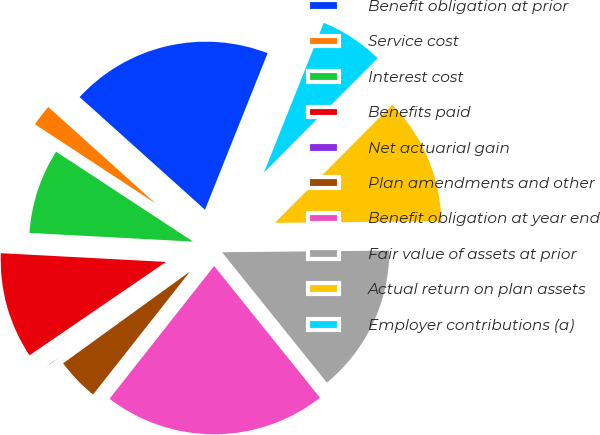<chart> <loc_0><loc_0><loc_500><loc_500><pie_chart><fcel>Benefit obligation at prior<fcel>Service cost<fcel>Interest cost<fcel>Benefits paid<fcel>Net actuarial gain<fcel>Plan amendments and other<fcel>Benefit obligation at year end<fcel>Fair value of assets at prior<fcel>Actual return on plan assets<fcel>Employer contributions (a)<nl><fcel>19.4%<fcel>2.41%<fcel>8.4%<fcel>10.39%<fcel>0.42%<fcel>4.41%<fcel>21.4%<fcel>14.38%<fcel>12.39%<fcel>6.4%<nl></chart> 